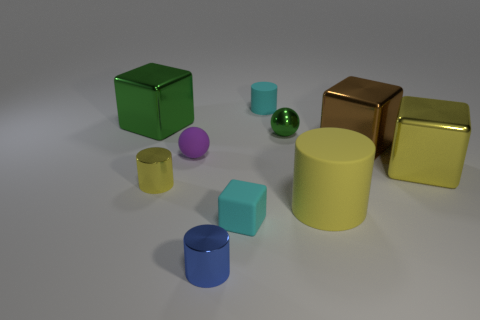Are there the same number of big yellow rubber cylinders that are in front of the yellow matte cylinder and small gray matte objects?
Give a very brief answer. Yes. The blue thing that is the same size as the purple rubber ball is what shape?
Offer a very short reply. Cylinder. What number of other things are there of the same shape as the blue shiny thing?
Provide a short and direct response. 3. Do the brown object and the matte cylinder in front of the green shiny ball have the same size?
Your response must be concise. Yes. How many things are big metallic blocks that are on the right side of the large yellow rubber cylinder or shiny balls?
Your response must be concise. 3. There is a yellow shiny object that is right of the green shiny ball; what is its shape?
Your response must be concise. Cube. Are there the same number of large yellow cubes in front of the big yellow metal object and brown metallic cubes that are left of the big matte cylinder?
Ensure brevity in your answer.  Yes. What color is the block that is both behind the tiny block and to the left of the large brown block?
Offer a very short reply. Green. The yellow object to the left of the green object that is to the right of the large green block is made of what material?
Provide a short and direct response. Metal. Do the purple rubber thing and the yellow rubber cylinder have the same size?
Ensure brevity in your answer.  No. 